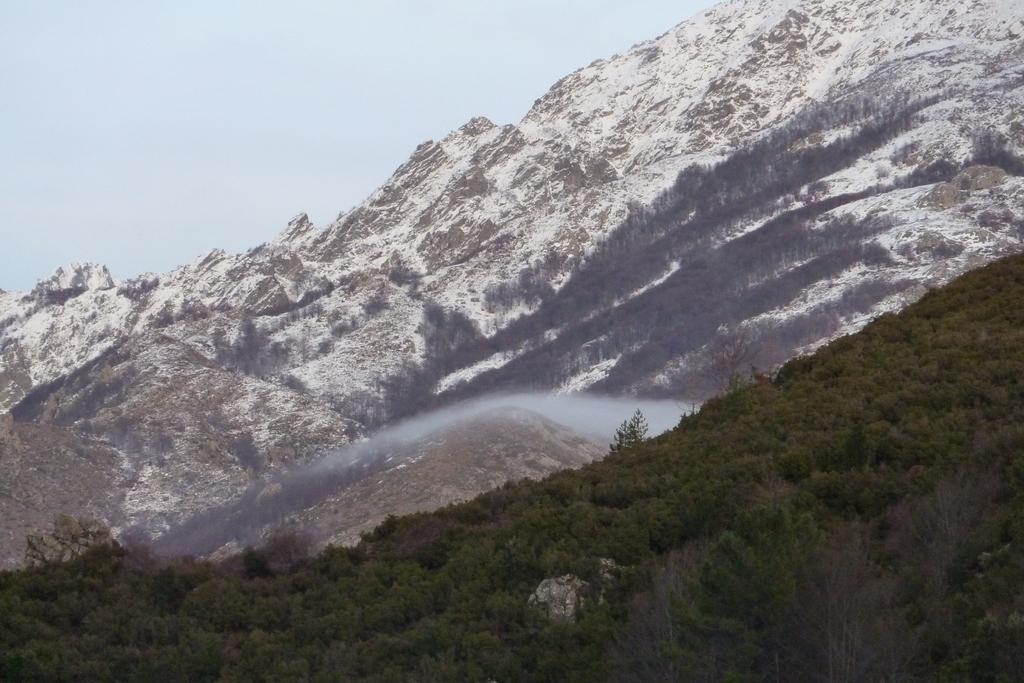Can you describe this image briefly? In this picture there are trees at the bottom side of the image and there are mountains in the background area of the image. 